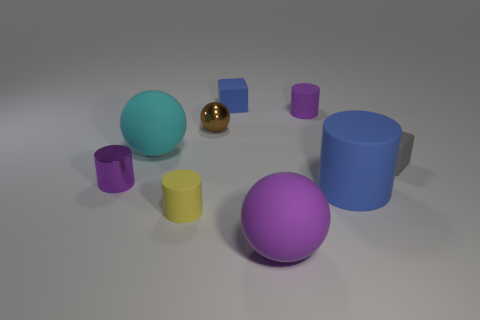There is a purple matte thing that is in front of the small metallic cylinder; what is its size?
Your response must be concise. Large. How many other things are the same color as the shiny sphere?
Provide a succinct answer. 0. There is a tiny purple cylinder that is on the left side of the rubber sphere that is on the right side of the brown metallic ball; what is its material?
Offer a very short reply. Metal. There is a block behind the large cyan rubber sphere; is its color the same as the large cylinder?
Give a very brief answer. Yes. How many other rubber things are the same shape as the small yellow matte thing?
Provide a succinct answer. 2. What size is the cyan object that is the same material as the purple sphere?
Ensure brevity in your answer.  Large. Are there any tiny matte objects in front of the shiny thing that is right of the small purple cylinder that is left of the small purple matte object?
Make the answer very short. Yes. Do the matte sphere that is left of the blue cube and the large blue matte cylinder have the same size?
Make the answer very short. Yes. What number of balls are the same size as the yellow object?
Ensure brevity in your answer.  1. The rubber cylinder that is the same color as the tiny metallic cylinder is what size?
Keep it short and to the point. Small. 